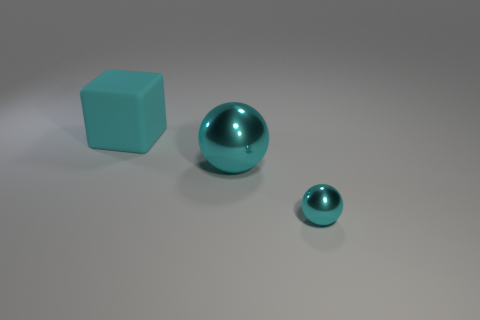What number of other things are the same color as the large matte thing?
Provide a short and direct response. 2. Is the number of small cyan things that are to the left of the tiny cyan object less than the number of cyan rubber things?
Keep it short and to the point. Yes. There is a shiny ball that is behind the metal thing that is in front of the cyan shiny ball that is behind the tiny object; what color is it?
Provide a short and direct response. Cyan. Are there any other things that are the same material as the block?
Make the answer very short. No. The other cyan metal object that is the same shape as the small cyan metallic object is what size?
Your response must be concise. Large. Are there fewer metallic balls that are left of the tiny cyan object than large cyan metal balls that are in front of the big metal sphere?
Offer a very short reply. No. The other cyan object that is made of the same material as the small cyan thing is what size?
Your answer should be very brief. Large. Is the color of the small metal thing the same as the big object that is right of the large matte block?
Offer a very short reply. Yes. What material is the cyan object that is both right of the large cyan cube and on the left side of the tiny sphere?
Your answer should be very brief. Metal. The other metal thing that is the same color as the small metallic thing is what size?
Keep it short and to the point. Large. 